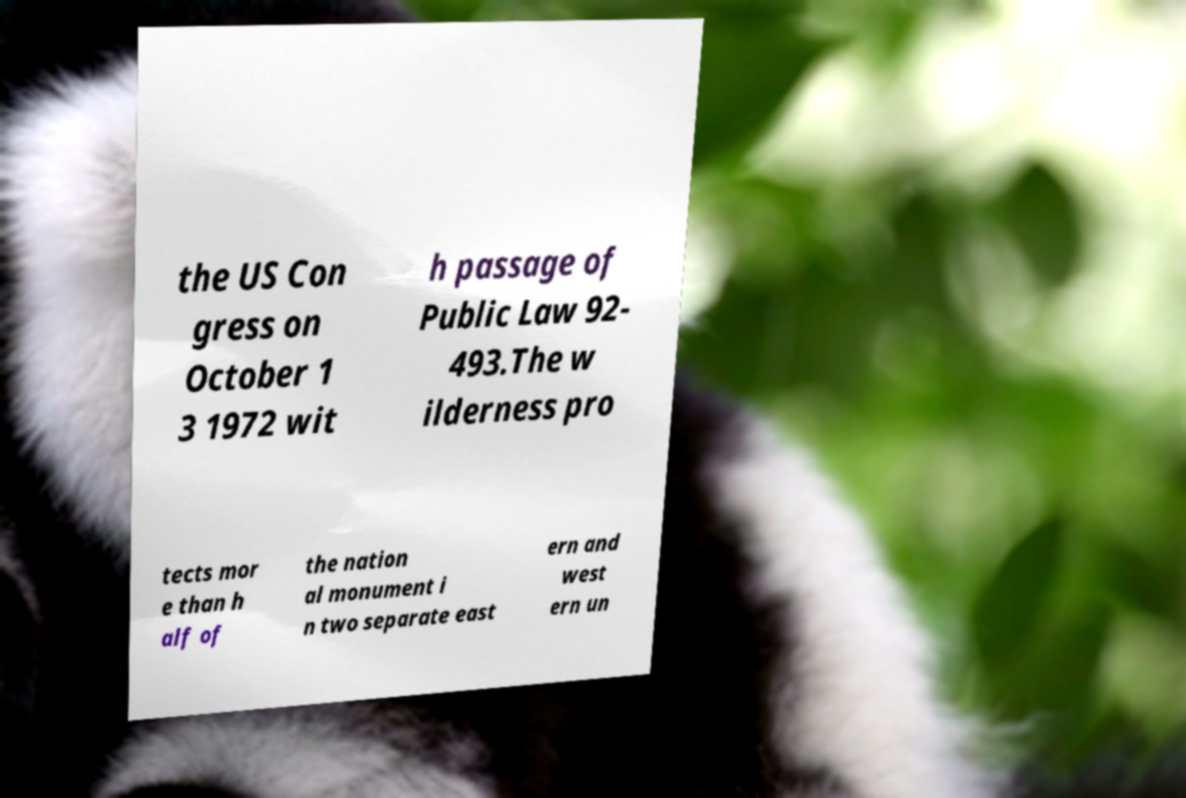For documentation purposes, I need the text within this image transcribed. Could you provide that? the US Con gress on October 1 3 1972 wit h passage of Public Law 92- 493.The w ilderness pro tects mor e than h alf of the nation al monument i n two separate east ern and west ern un 